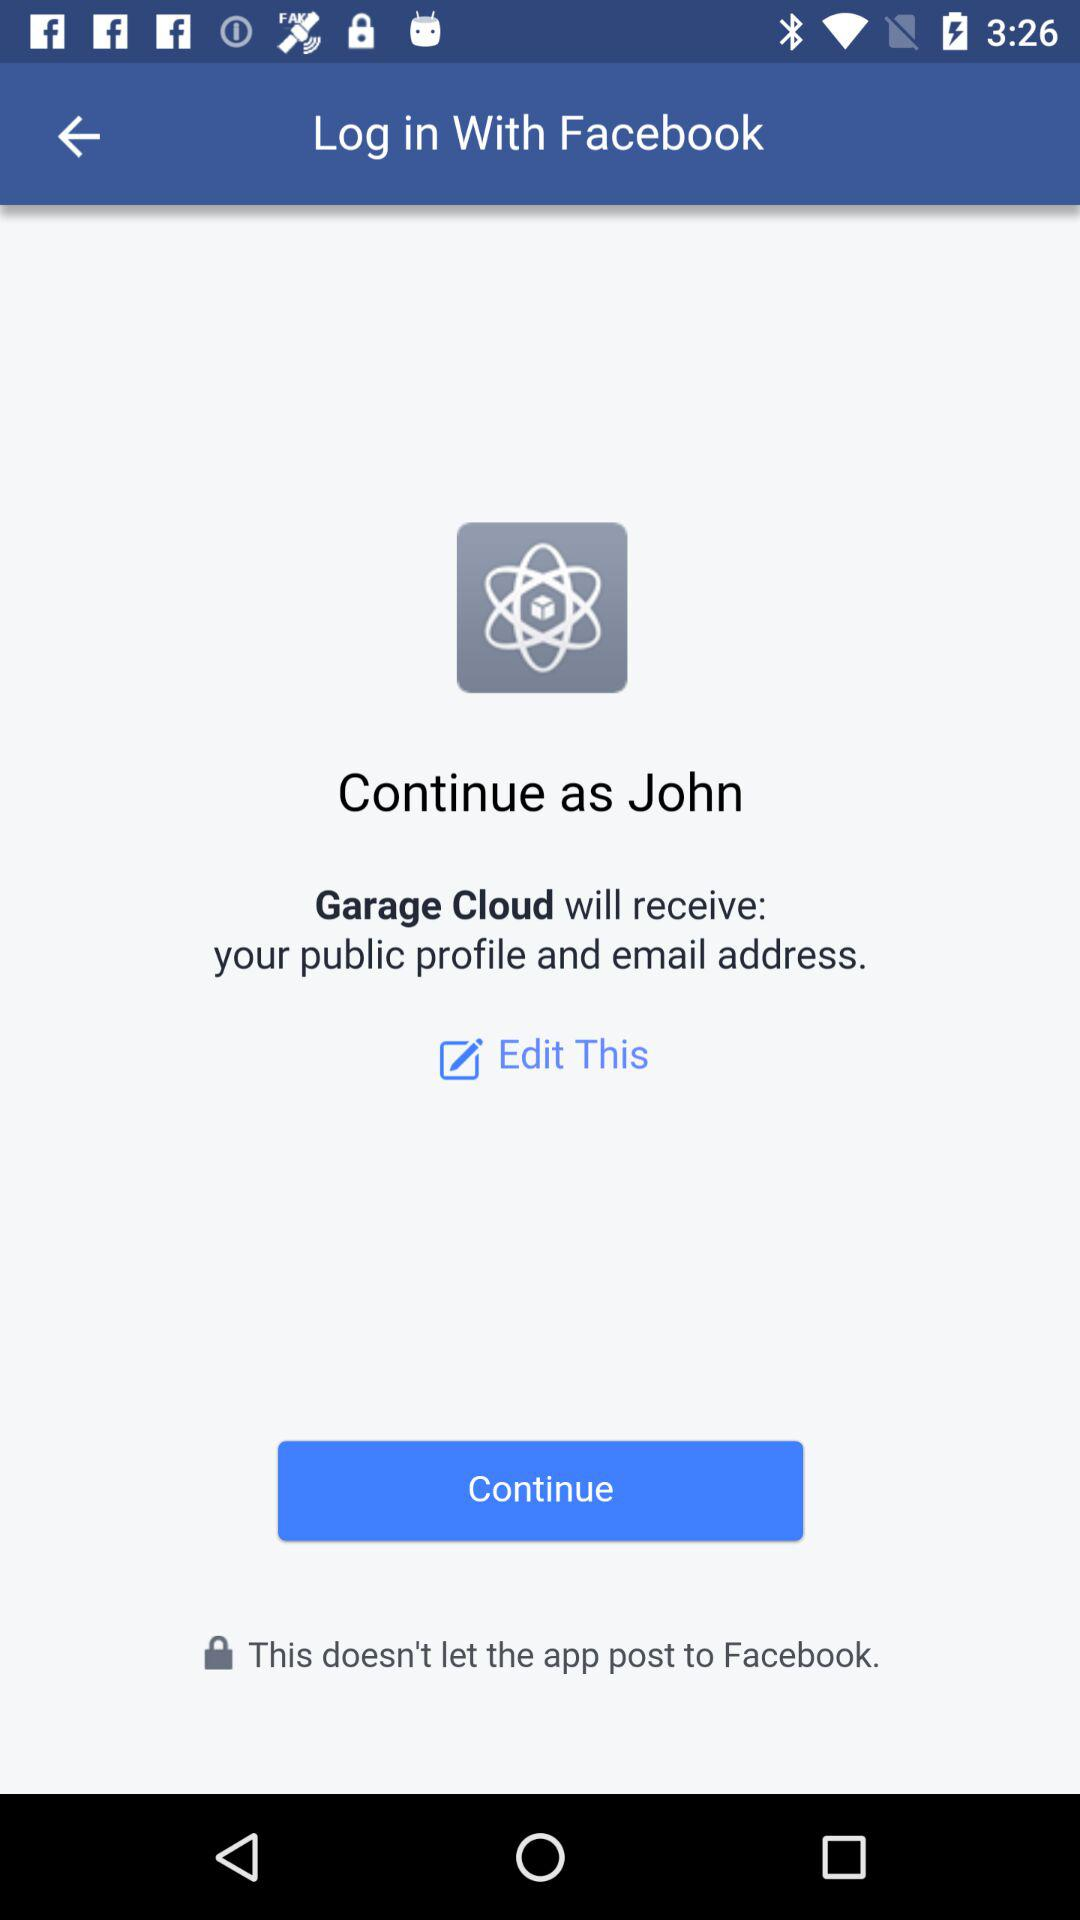What application will receive my public profile and email address? The application name is "Garage Cloud". 